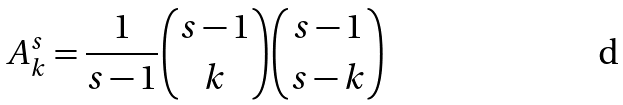Convert formula to latex. <formula><loc_0><loc_0><loc_500><loc_500>A ^ { s } _ { k } = \frac { 1 } { s - 1 } \binom { s - 1 } { k } \binom { s - 1 } { s - k }</formula> 